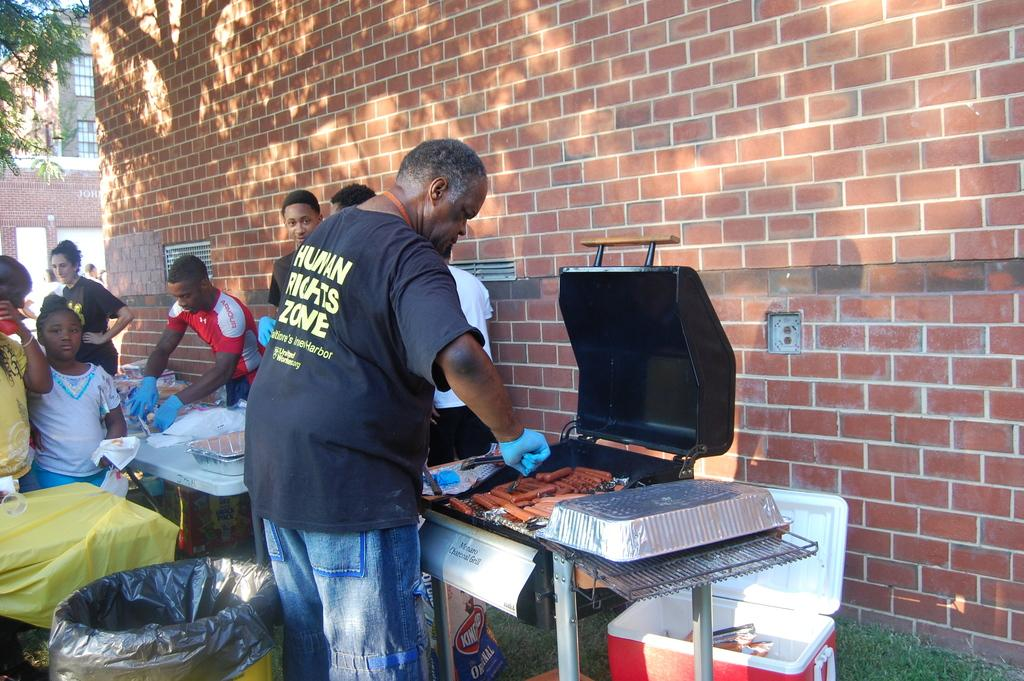<image>
Give a short and clear explanation of the subsequent image. a man grilling hotdogs while wearing a HUman Rights Zone t-shirt 